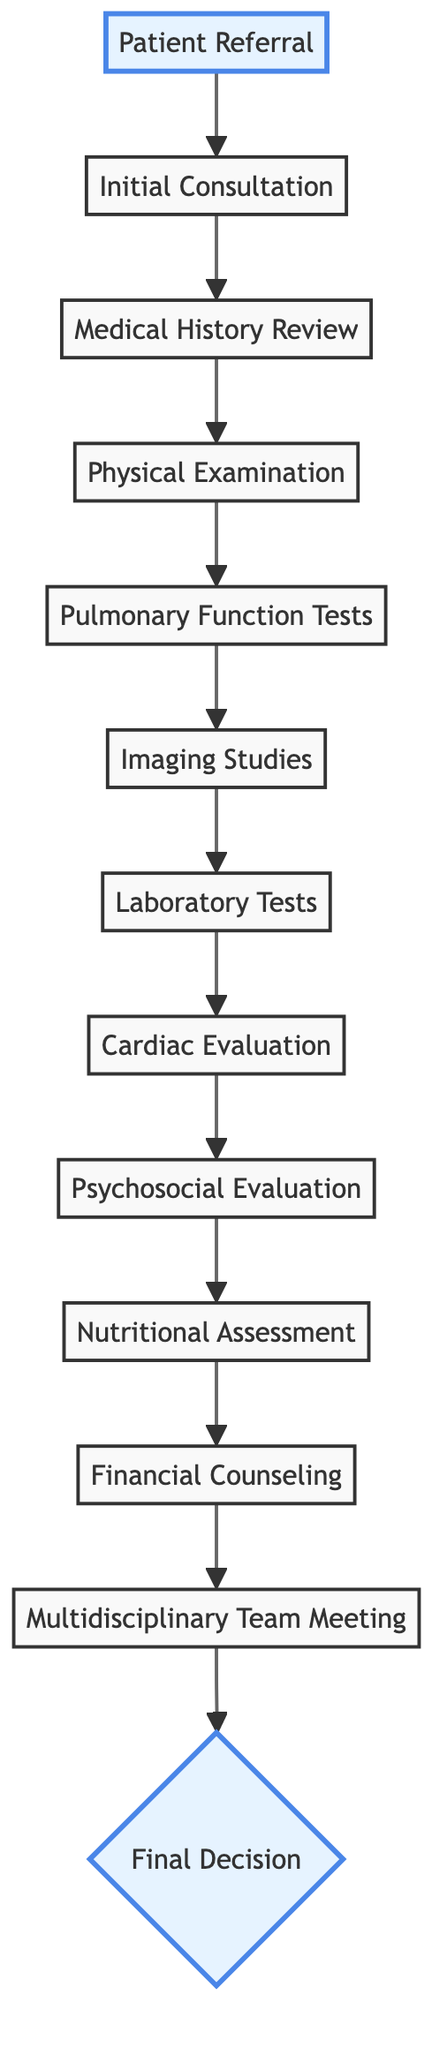What is the first step in the process? The first step in the block diagram is "Patient Referral," which indicates the initial action taken by the primary care physician or pulmonologist for lung transplant evaluation.
Answer: Patient Referral How many evaluations are conducted before the Multidisciplinary Team Meeting? The diagram lists a total of 10 evaluations from "Initial Consultation" to "Financial Counseling" that must be completed prior to the "Multidisciplinary Team Meeting."
Answer: 10 What type of evaluation follows the Pulmonary Function Tests? After the "Pulmonary Function Tests," the next evaluation in the diagram is "Imaging Studies," suggesting that imaging is performed to visualize the lung structures and function.
Answer: Imaging Studies Which meeting discusses the collective decision on lung transplant candidacy? The "Multidisciplinary Team Meeting" is where specialists discuss and review all evaluation results to decide on the lung transplant candidacy.
Answer: Multidisciplinary Team Meeting What is the final outcome of the evaluation process? The final outcome of the evaluation process, as shown in the diagram, is the "Final Decision," where the patient is informed about their status regarding lung transplant candidacy.
Answer: Final Decision What type of specialist evaluates the patient’s nutritional status? The "Nutritional Assessment" is conducted by a dietitian who evaluates the patient’s nutritional status and recommends dietary changes.
Answer: Dietitian Which evaluation comes before the Psychosocial Evaluation? Before the "Psychosocial Evaluation," the "Cardiac Evaluation" is conducted, which includes assessments like ECG and echocardiograms to assess heart function.
Answer: Cardiac Evaluation How many diagnostic categories are there before the final decision? Before the "Final Decision," there are 11 diagnostic categories listed, from "Patient Referral" to "Financial Counseling," as part of the evaluation process.
Answer: 11 What document might be reviewed during the Financial Counseling step? During "Financial Counseling," the financial advisor discusses "insurance coverage," which is crucial for determining how transplantation costs will be managed.
Answer: Insurance coverage 